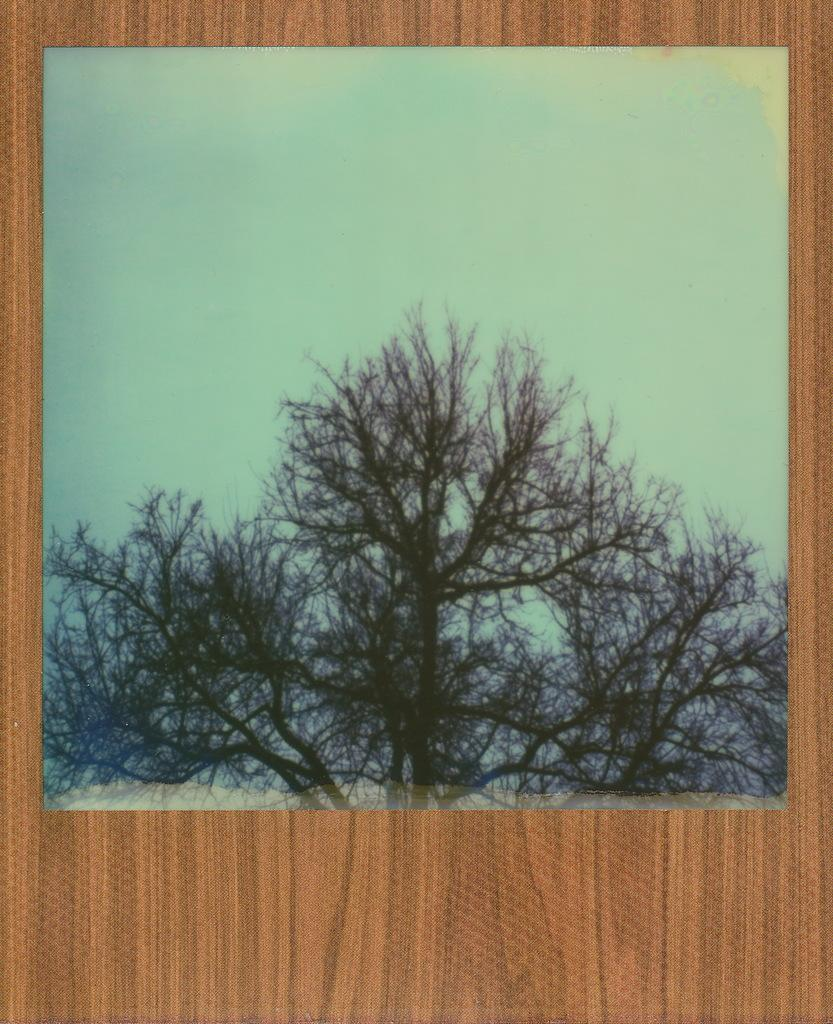What object is present in the image that typically holds a photograph? There is a photo frame in the image. What type of natural scenery can be seen in the image? Trees are visible in the image. What part of the natural environment is visible in the image? The sky is visible in the image. On what surface is the photo frame placed? The photo frame is placed on a wooden surface. What type of riddle can be seen written on the photo frame in the image? There is no riddle written on the photo frame in the image. What type of relation can be seen between the people in the photo frame? There is no photo visible in the image, so it is impossible to determine any relation between people. 